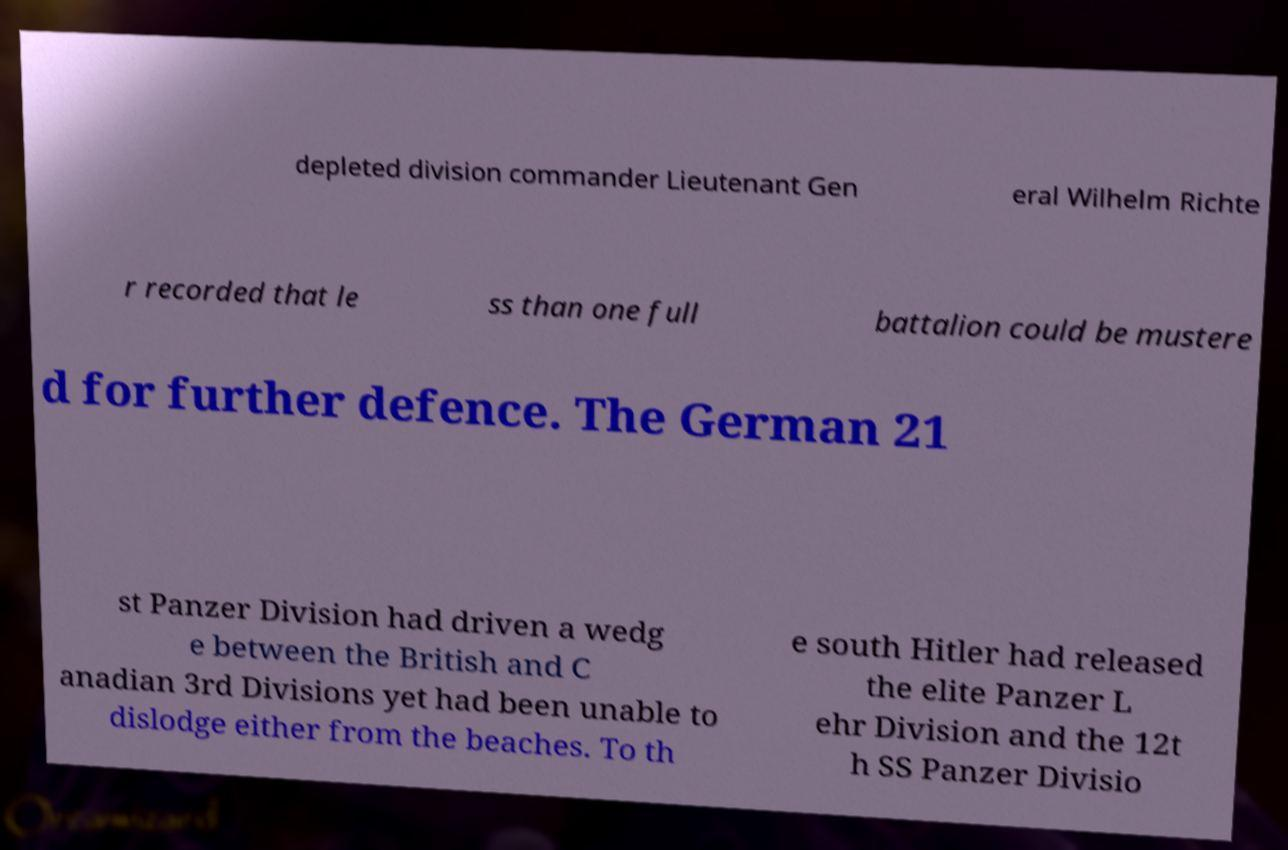Please read and relay the text visible in this image. What does it say? depleted division commander Lieutenant Gen eral Wilhelm Richte r recorded that le ss than one full battalion could be mustere d for further defence. The German 21 st Panzer Division had driven a wedg e between the British and C anadian 3rd Divisions yet had been unable to dislodge either from the beaches. To th e south Hitler had released the elite Panzer L ehr Division and the 12t h SS Panzer Divisio 